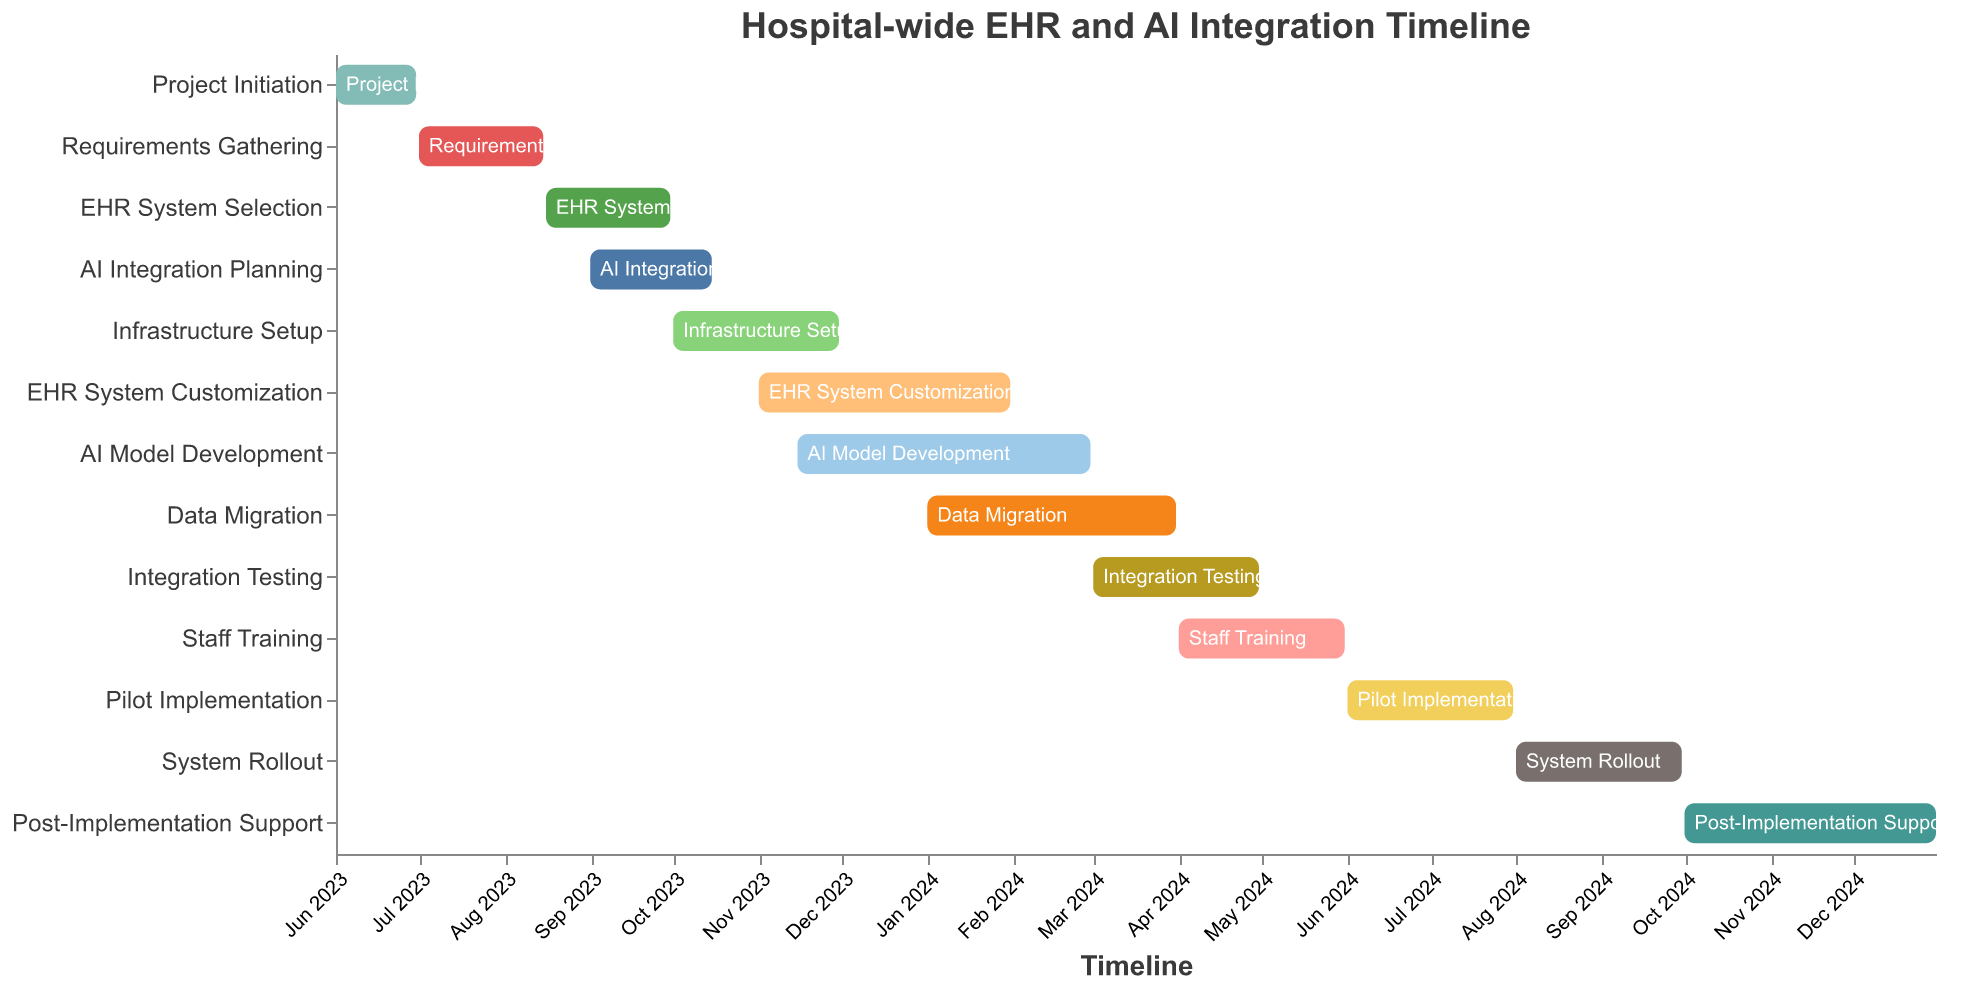What's the duration of the "AI Model Development" task? The "AI Model Development" task starts on 2023-11-15 and ends on 2024-02-29. As given, its duration is 107 days.
Answer: 107 days Which task has the shortest duration? By examining the durations of all tasks, the "Project Initiation" task has the shortest duration of 30 days.
Answer: Project Initiation What tasks are being performed in November 2023? By looking at the timeline for November 2023, the tasks that overlap with this period are "Infrastructure Setup", "EHR System Customization", and "AI Model Development".
Answer: Infrastructure Setup, EHR System Customization, AI Model Development When does the "Data Migration" task start and end? The "Data Migration" task starts on 2024-01-01 and ends on 2024-03-31, as shown in the Gantt chart.
Answer: 2024-01-01 to 2024-03-31 Which task has the longest duration? By checking the durations of all tasks, the "AI Model Development" task has the longest duration of 107 days.
Answer: AI Model Development How long is the total time span from the start of "Project Initiation" to the end of "Post-Implementation Support"? The "Project Initiation" task begins on 2023-06-01, and "Post-Implementation Support" ends on 2024-12-31. The total timespan can be calculated from June 2023 to December 2024, which is 19 months.
Answer: 19 months In which month and year does "Staff Training" begin? According to the timeline, "Staff Training" begins in April 2024.
Answer: April 2024 Which task finishes last? The "Post-Implementation Support" task ends on 2024-12-31, making it the last task to finish.
Answer: Post-Implementation Support Which tasks overlap with the "Pilot Implementation" phase? Checking the "Pilot Implementation" phase from 2024-06-01 to 2024-07-31, the overlapping tasks are "Staff Training" and "System Rollout".
Answer: Staff Training, System Rollout Is there any task that completely overlaps with the "Integration Testing" period? The "Integration Testing" is from 2024-03-01 to 2024-04-30. "Staff Training" also starts and ends within this period, making it completely overlapping.
Answer: Staff Training 